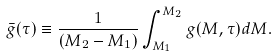Convert formula to latex. <formula><loc_0><loc_0><loc_500><loc_500>\bar { g } ( \tau ) \equiv \frac { 1 } { ( M _ { 2 } - M _ { 1 } ) } \int _ { M _ { 1 } } ^ { M _ { 2 } } g ( M , \tau ) d M .</formula> 